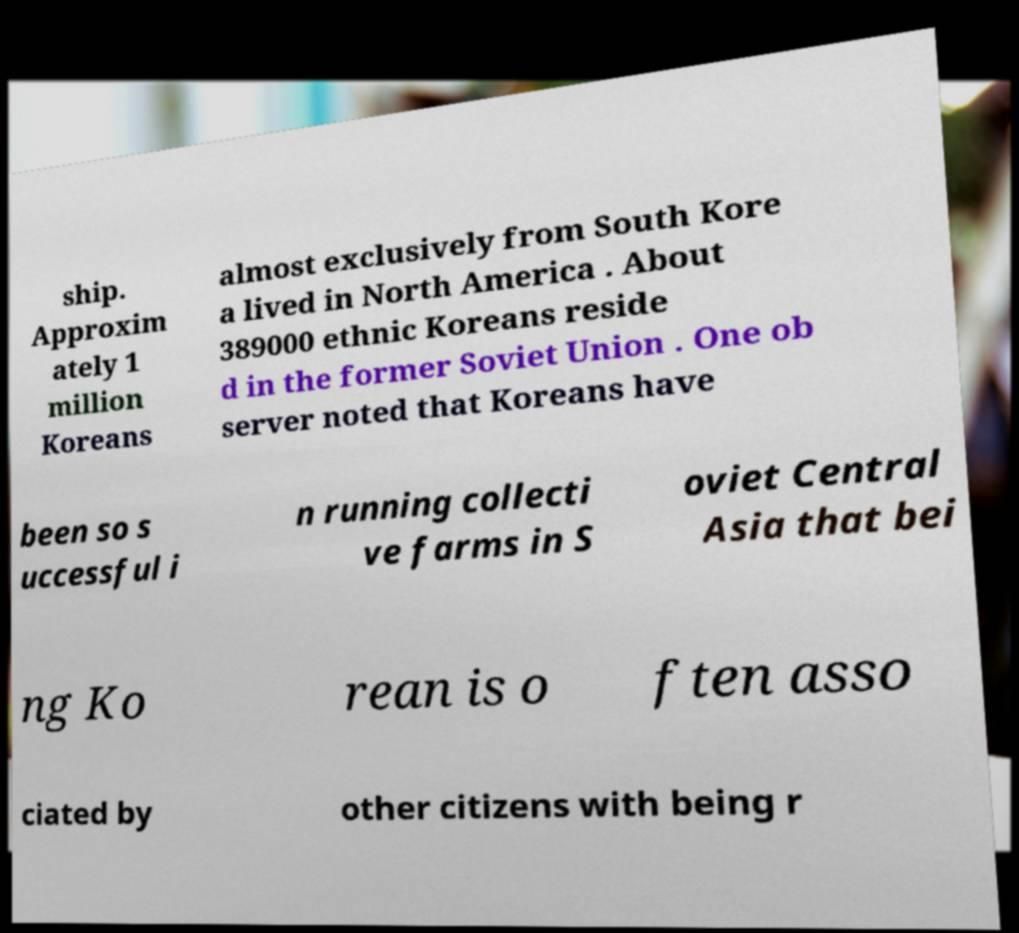Can you accurately transcribe the text from the provided image for me? ship. Approxim ately 1 million Koreans almost exclusively from South Kore a lived in North America . About 389000 ethnic Koreans reside d in the former Soviet Union . One ob server noted that Koreans have been so s uccessful i n running collecti ve farms in S oviet Central Asia that bei ng Ko rean is o ften asso ciated by other citizens with being r 